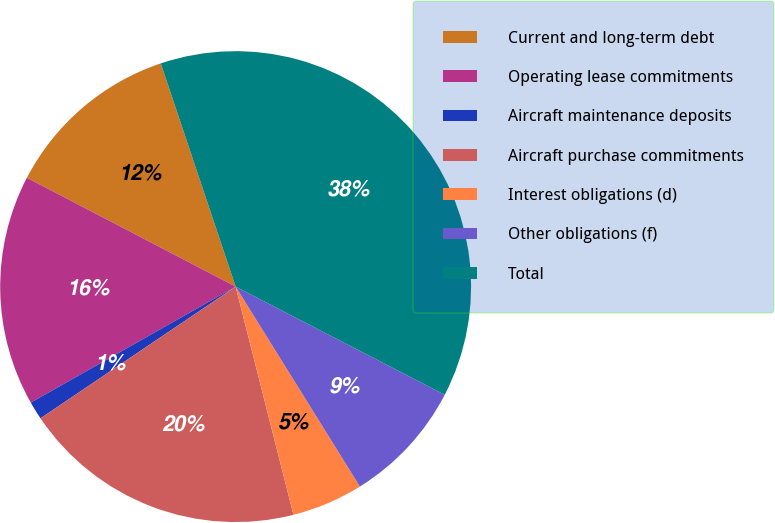Convert chart. <chart><loc_0><loc_0><loc_500><loc_500><pie_chart><fcel>Current and long-term debt<fcel>Operating lease commitments<fcel>Aircraft maintenance deposits<fcel>Aircraft purchase commitments<fcel>Interest obligations (d)<fcel>Other obligations (f)<fcel>Total<nl><fcel>12.2%<fcel>15.85%<fcel>1.25%<fcel>19.5%<fcel>4.9%<fcel>8.55%<fcel>37.75%<nl></chart> 